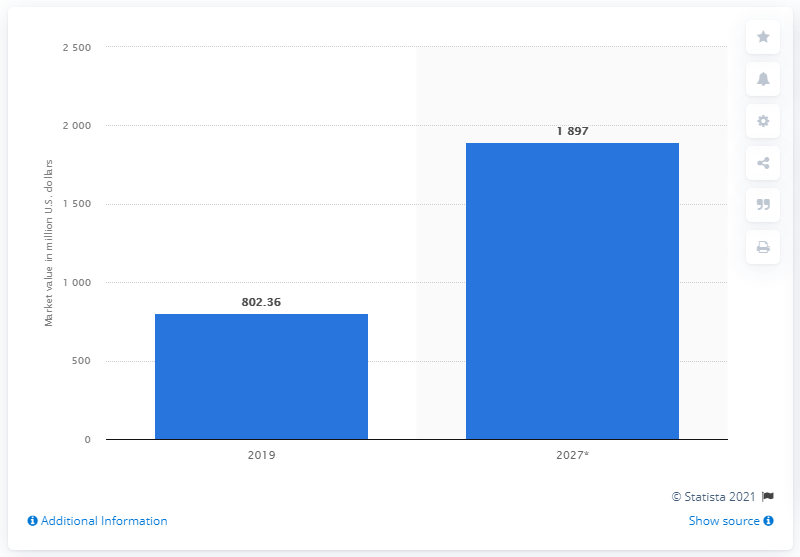Indicate a few pertinent items in this graphic. By 2027, the market value of N95 masks is predicted to be approximately 1897. The market value of N95 masks in 2019 was approximately $802.36. 